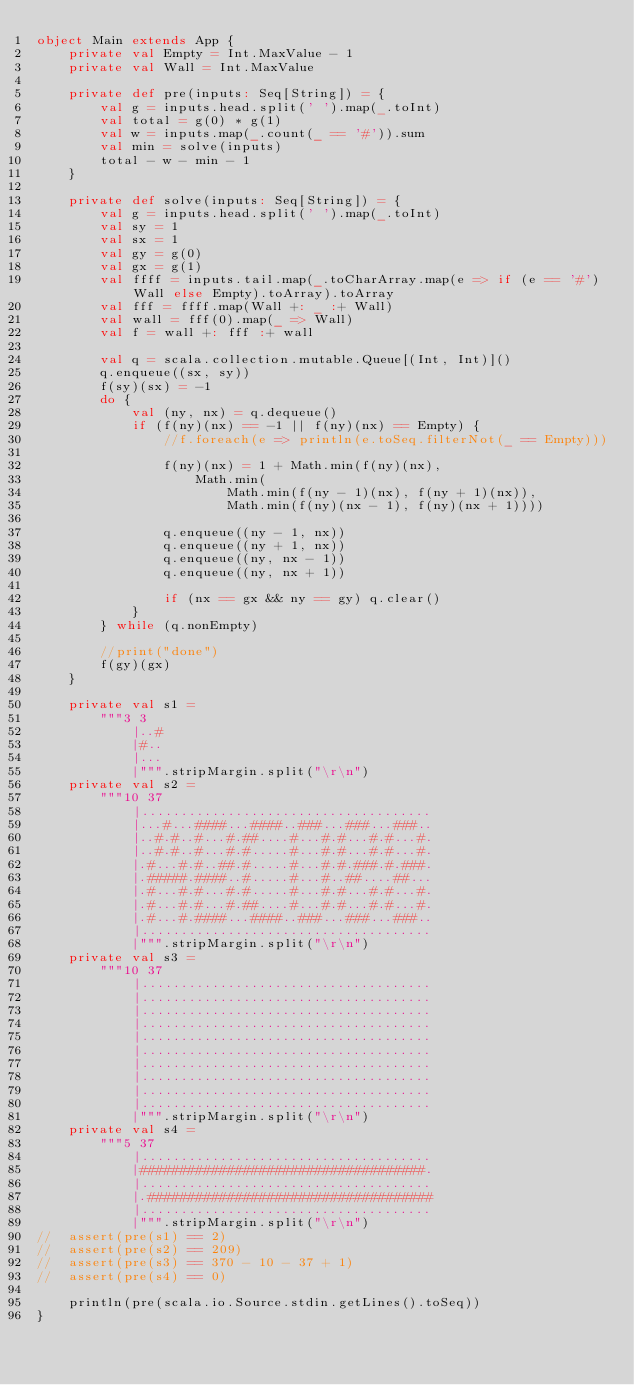Convert code to text. <code><loc_0><loc_0><loc_500><loc_500><_Scala_>object Main extends App {
	private val Empty = Int.MaxValue - 1
	private val Wall = Int.MaxValue

	private def pre(inputs: Seq[String]) = {
		val g = inputs.head.split(' ').map(_.toInt)
		val total = g(0) * g(1)
		val w = inputs.map(_.count(_ == '#')).sum
		val min = solve(inputs)
		total - w - min - 1
	}

	private def solve(inputs: Seq[String]) = {
		val g = inputs.head.split(' ').map(_.toInt)
		val sy = 1
		val sx = 1
		val gy = g(0)
		val gx = g(1)
		val ffff = inputs.tail.map(_.toCharArray.map(e => if (e == '#') Wall else Empty).toArray).toArray
		val fff = ffff.map(Wall +: _ :+ Wall)
		val wall = fff(0).map(_ => Wall)
		val f = wall +: fff :+ wall

		val q = scala.collection.mutable.Queue[(Int, Int)]()
		q.enqueue((sx, sy))
		f(sy)(sx) = -1
		do {
			val (ny, nx) = q.dequeue()
			if (f(ny)(nx) == -1 || f(ny)(nx) == Empty) {
				//f.foreach(e => println(e.toSeq.filterNot(_ == Empty)))

				f(ny)(nx) = 1 + Math.min(f(ny)(nx),
					Math.min(
						Math.min(f(ny - 1)(nx), f(ny + 1)(nx)),
						Math.min(f(ny)(nx - 1), f(ny)(nx + 1))))

				q.enqueue((ny - 1, nx))
				q.enqueue((ny + 1, nx))
				q.enqueue((ny, nx - 1))
				q.enqueue((ny, nx + 1))

				if (nx == gx && ny == gy) q.clear()
			}
		} while (q.nonEmpty)

		//print("done")
		f(gy)(gx)
	}

	private val s1 =
		"""3 3
			|..#
			|#..
			|...
			|""".stripMargin.split("\r\n")
	private val s2 =
		"""10 37
			|.....................................
			|...#...####...####..###...###...###..
			|..#.#..#...#.##....#...#.#...#.#...#.
			|..#.#..#...#.#.....#...#.#...#.#...#.
			|.#...#.#..##.#.....#...#.#.###.#.###.
			|.#####.####..#.....#...#..##....##...
			|.#...#.#...#.#.....#...#.#...#.#...#.
			|.#...#.#...#.##....#...#.#...#.#...#.
			|.#...#.####...####..###...###...###..
			|.....................................
			|""".stripMargin.split("\r\n")
	private val s3 =
		"""10 37
			|.....................................
			|.....................................
			|.....................................
			|.....................................
			|.....................................
			|.....................................
			|.....................................
			|.....................................
			|.....................................
			|.....................................
			|""".stripMargin.split("\r\n")
	private val s4 =
		"""5 37
			|.....................................
			|####################################.
			|.....................................
			|.####################################
			|.....................................
			|""".stripMargin.split("\r\n")
//	assert(pre(s1) == 2)
//	assert(pre(s2) == 209)
//	assert(pre(s3) == 370 - 10 - 37 + 1)
//	assert(pre(s4) == 0)

	println(pre(scala.io.Source.stdin.getLines().toSeq))
}
</code> 